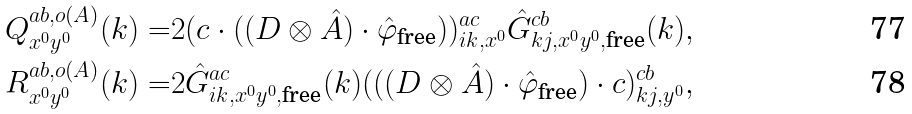Convert formula to latex. <formula><loc_0><loc_0><loc_500><loc_500>Q ^ { a b , o ( A ) } _ { x ^ { 0 } y ^ { 0 } } ( { k } ) = & 2 ( c \cdot ( ( D \otimes \hat { A } ) \cdot \hat { \varphi } _ { \text {free} } ) ) ^ { a c } _ { i k , x ^ { 0 } } \hat { G } ^ { c b } _ { k j , x ^ { 0 } y ^ { 0 } , { \text {free} } } ( { k } ) , \\ R ^ { a b , o ( A ) } _ { x ^ { 0 } y ^ { 0 } } ( { k } ) = & 2 \hat { G } ^ { a c } _ { i k , x ^ { 0 } y ^ { 0 } , { \text {free} } } ( { k } ) ( ( ( D \otimes \hat { A } ) \cdot \hat { \varphi } _ { \text {free} } ) \cdot c ) ^ { c b } _ { k j , y ^ { 0 } } ,</formula> 